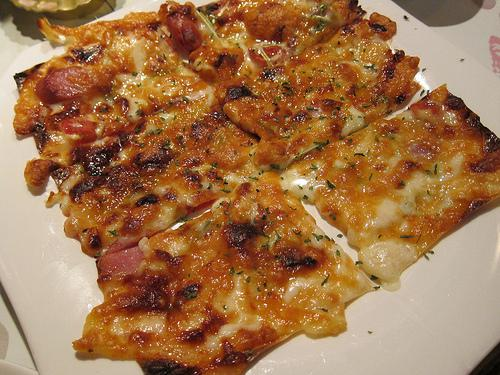Question: what is on the plate?
Choices:
A. Food.
B. Pizza.
C. Pasta.
D. Carrots.
Answer with the letter. Answer: A Question: when was this photo taken?
Choices:
A. During a meal.
B. Morning.
C. Yesterday.
D. Last week.
Answer with the letter. Answer: A Question: what is on top of the food?
Choices:
A. Sauce.
B. Cheese.
C. Mold.
D. Bacon bits.
Answer with the letter. Answer: B 